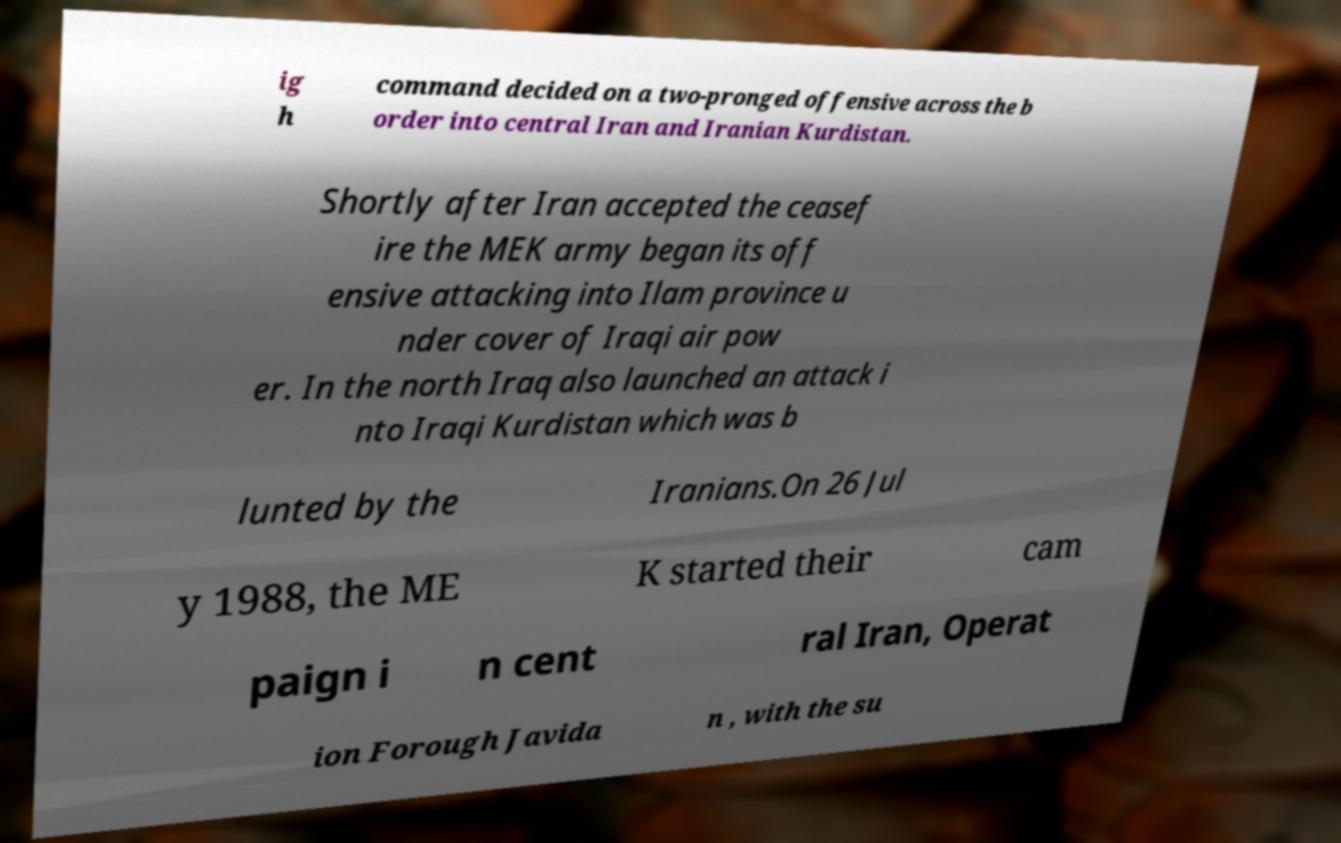Can you accurately transcribe the text from the provided image for me? ig h command decided on a two-pronged offensive across the b order into central Iran and Iranian Kurdistan. Shortly after Iran accepted the ceasef ire the MEK army began its off ensive attacking into Ilam province u nder cover of Iraqi air pow er. In the north Iraq also launched an attack i nto Iraqi Kurdistan which was b lunted by the Iranians.On 26 Jul y 1988, the ME K started their cam paign i n cent ral Iran, Operat ion Forough Javida n , with the su 